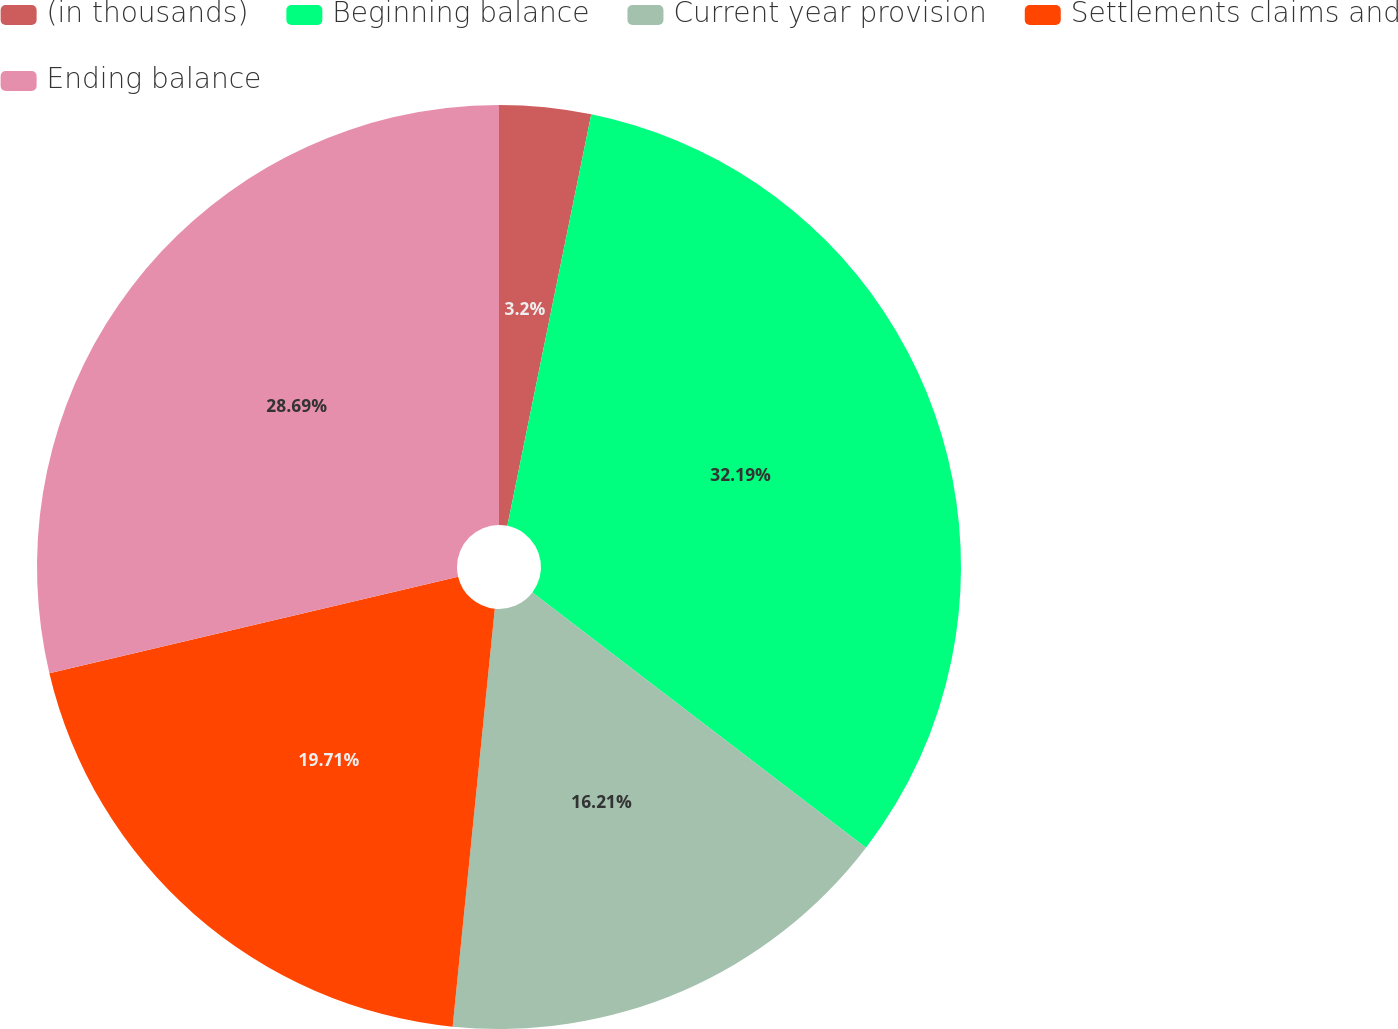Convert chart to OTSL. <chart><loc_0><loc_0><loc_500><loc_500><pie_chart><fcel>(in thousands)<fcel>Beginning balance<fcel>Current year provision<fcel>Settlements claims and<fcel>Ending balance<nl><fcel>3.2%<fcel>32.19%<fcel>16.21%<fcel>19.71%<fcel>28.69%<nl></chart> 